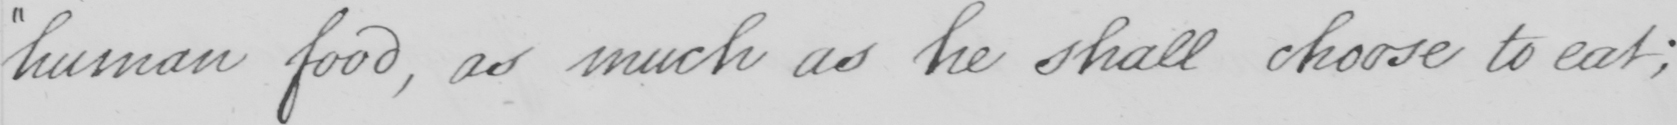Can you tell me what this handwritten text says? human food , as much as he shall choose to eat ; 